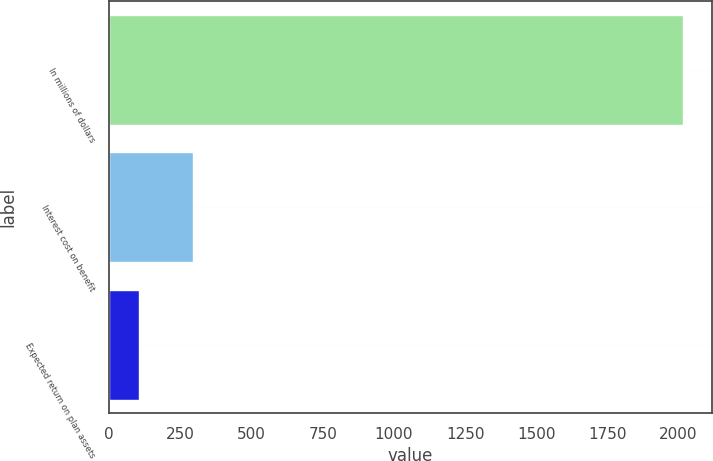Convert chart to OTSL. <chart><loc_0><loc_0><loc_500><loc_500><bar_chart><fcel>In millions of dollars<fcel>Interest cost on benefit<fcel>Expected return on plan assets<nl><fcel>2015<fcel>296<fcel>105<nl></chart> 